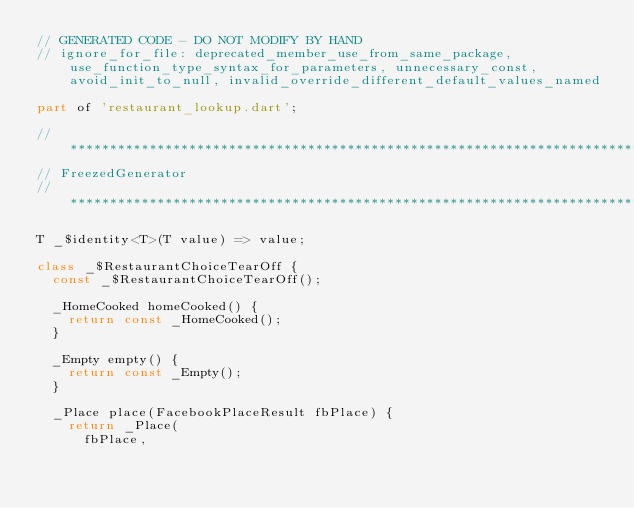<code> <loc_0><loc_0><loc_500><loc_500><_Dart_>// GENERATED CODE - DO NOT MODIFY BY HAND
// ignore_for_file: deprecated_member_use_from_same_package, use_function_type_syntax_for_parameters, unnecessary_const, avoid_init_to_null, invalid_override_different_default_values_named

part of 'restaurant_lookup.dart';

// **************************************************************************
// FreezedGenerator
// **************************************************************************

T _$identity<T>(T value) => value;

class _$RestaurantChoiceTearOff {
  const _$RestaurantChoiceTearOff();

  _HomeCooked homeCooked() {
    return const _HomeCooked();
  }

  _Empty empty() {
    return const _Empty();
  }

  _Place place(FacebookPlaceResult fbPlace) {
    return _Place(
      fbPlace,</code> 